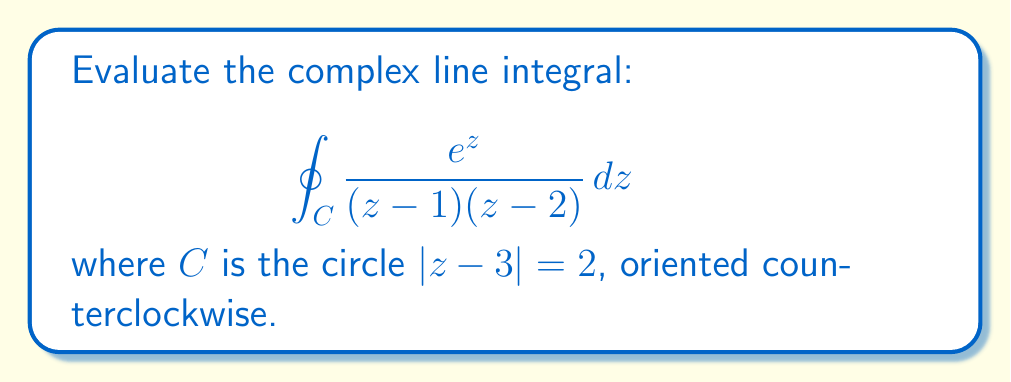Help me with this question. Let's approach this step-by-step using Cauchy's Integral Formula:

1) First, we need to identify the singularities inside the contour $C$. The function has singularities at $z=1$ and $z=2$.

2) Let's check if these points are inside the circle $|z-3| = 2$:
   For $z=1$: $|1-3| = 2$, which is on the circle.
   For $z=2$: $|2-3| = 1$, which is inside the circle.

3) Only $z=2$ is inside the contour, so we'll apply Cauchy's Integral Formula to this point.

4) Cauchy's Integral Formula states:
   $$ \oint_C \frac{f(z)}{z-a} dz = 2\pi i f(a) $$
   where $f(z)$ is analytic inside and on $C$ except at $z=a$.

5) In our case, $f(z) = \frac{e^z}{z-1}$ and $a=2$.

6) Applying the formula:
   $$ \oint_C \frac{e^z}{(z-1)(z-2)} dz = 2\pi i \frac{e^2}{2-1} = 2\pi i e^2 $$

7) Therefore, the value of the integral is $2\pi i e^2$.
Answer: $2\pi i e^2$ 